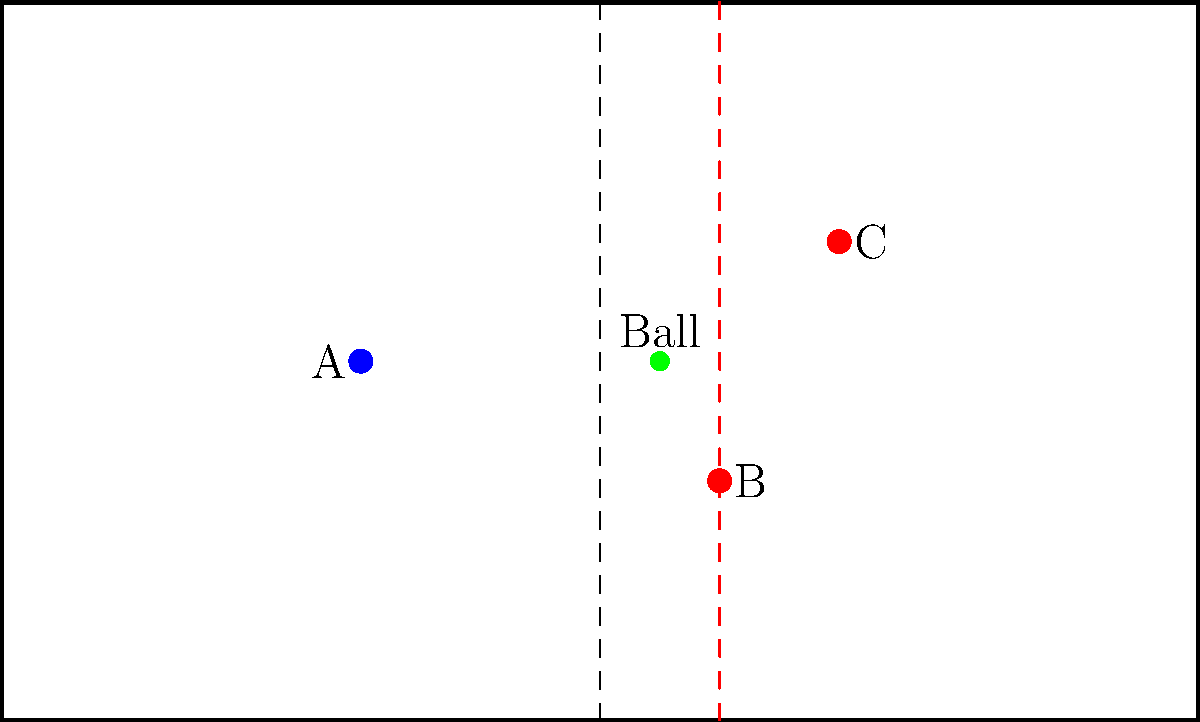In the simplified pitch layout above, player A (blue) is attempting to pass the ball to teammates B and C (red). The ball is currently at position (55, 30). Determine the x-coordinate of the offside line, considering that the offside position is judged at the moment the ball is played by player A. Assume the pitch dimensions are 100 units long and 60 units wide. To determine the x-coordinate of the offside line, we need to follow these steps:

1) The offside line is determined by the position of the second-last opponent (including the goalkeeper) at the moment the ball is played.

2) In this simplified scenario, we only see two opponent players (B and C in red), so we'll assume one of them represents the goalkeeper.

3) The offside line will be in line with the opponent player closest to their own goal line (excluding the goalkeeper).

4) Player B is at x-coordinate 60, and player C is at x-coordinate 70.

5) Since 60 < 70, player B is closer to their own goal line.

6) Therefore, the offside line is aligned with player B's position.

The x-coordinate of the offside line is the same as player B's x-coordinate, which is 60.
Answer: 60 